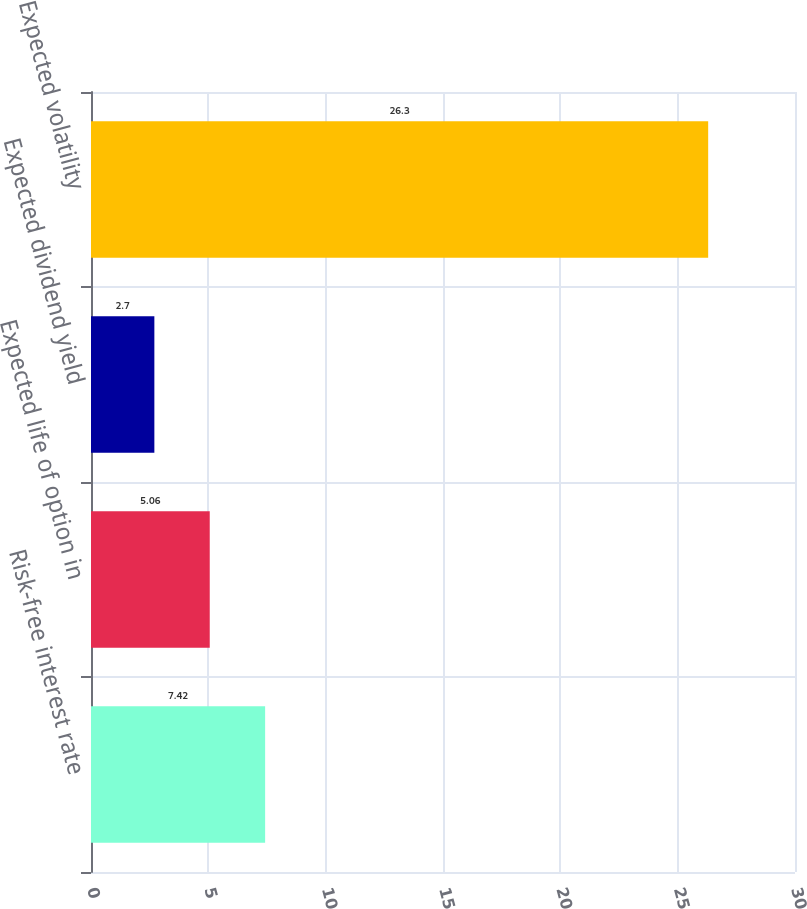<chart> <loc_0><loc_0><loc_500><loc_500><bar_chart><fcel>Risk-free interest rate<fcel>Expected life of option in<fcel>Expected dividend yield<fcel>Expected volatility<nl><fcel>7.42<fcel>5.06<fcel>2.7<fcel>26.3<nl></chart> 